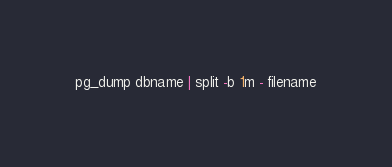Convert code to text. <code><loc_0><loc_0><loc_500><loc_500><_SQL_>pg_dump dbname | split -b 1m - filename
</code> 